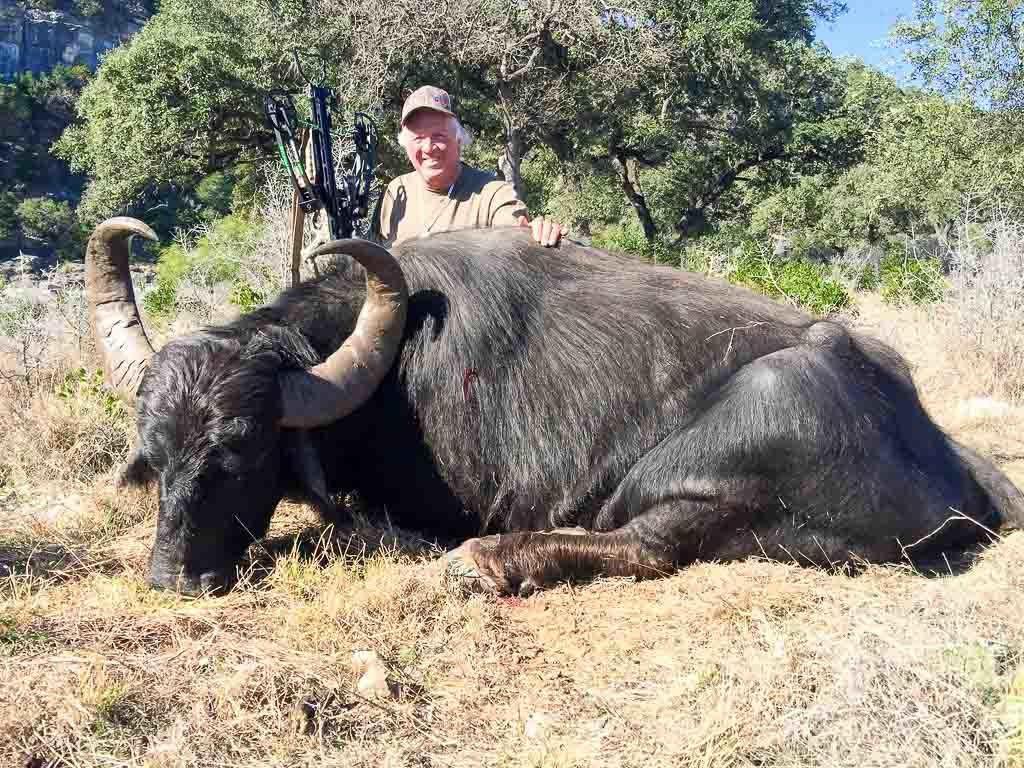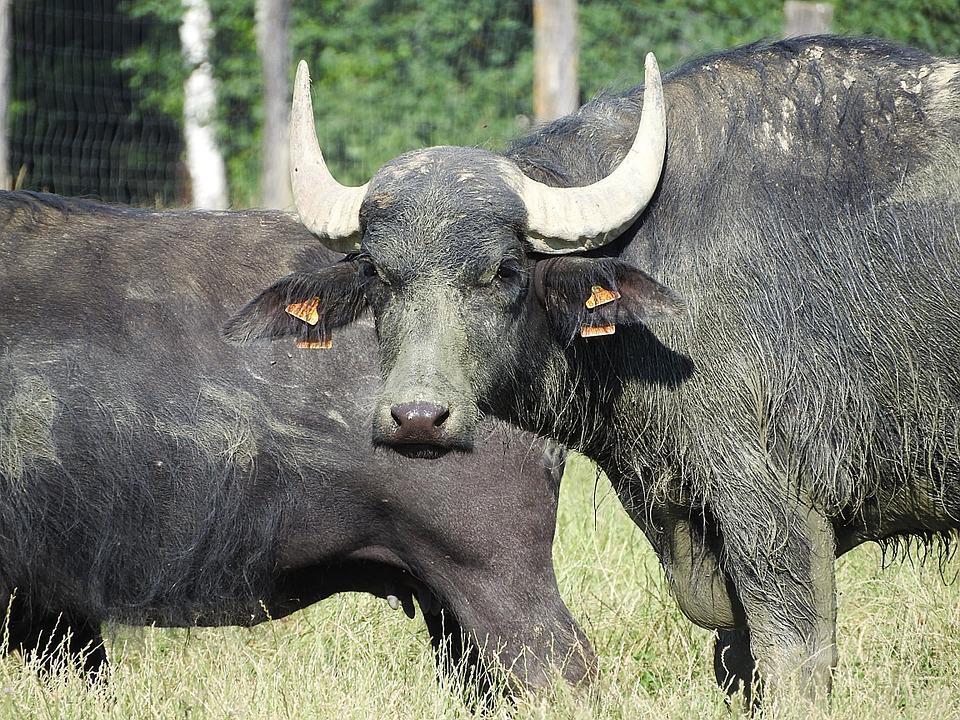The first image is the image on the left, the second image is the image on the right. Evaluate the accuracy of this statement regarding the images: "An image shows an ox-type animal in the mud.". Is it true? Answer yes or no. No. 